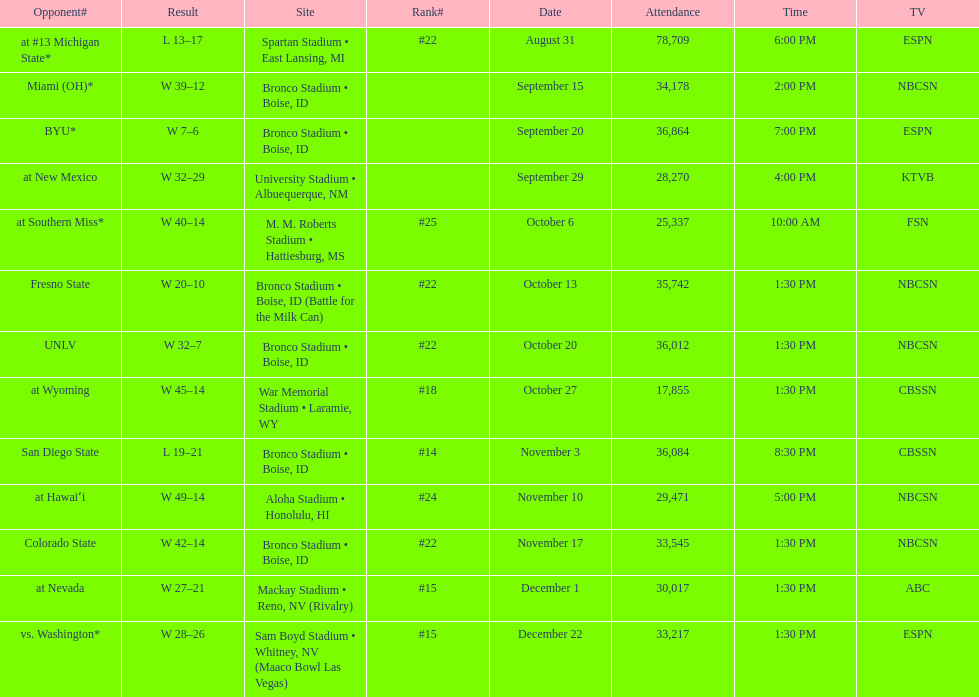Which team has the highest rank among those listed? San Diego State. 